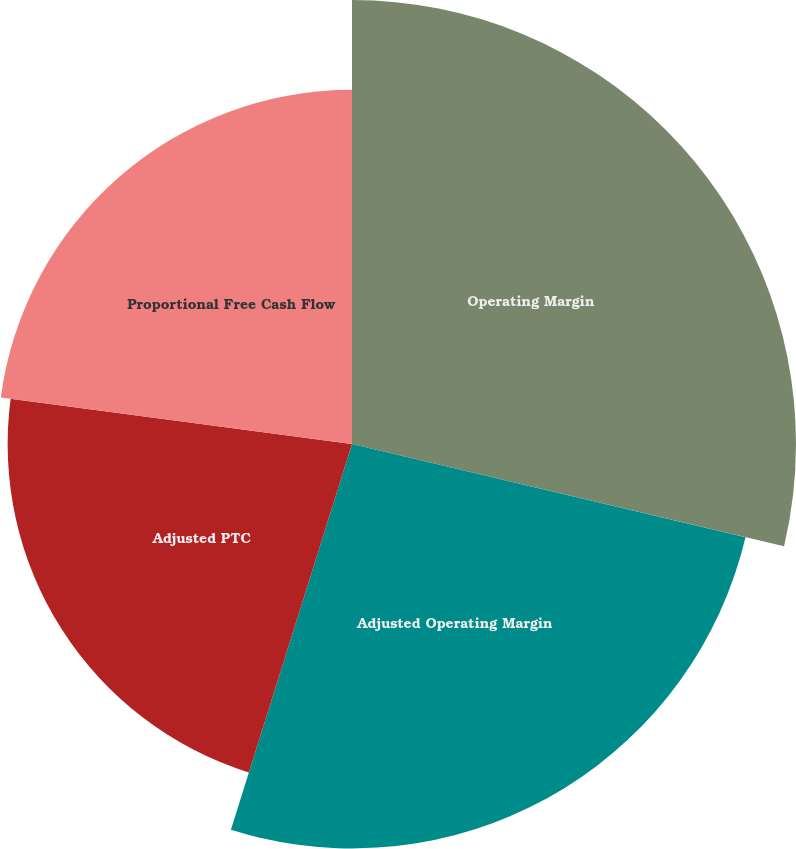Convert chart to OTSL. <chart><loc_0><loc_0><loc_500><loc_500><pie_chart><fcel>Operating Margin<fcel>Adjusted Operating Margin<fcel>Adjusted PTC<fcel>Proportional Free Cash Flow<nl><fcel>28.7%<fcel>26.14%<fcel>22.26%<fcel>22.9%<nl></chart> 